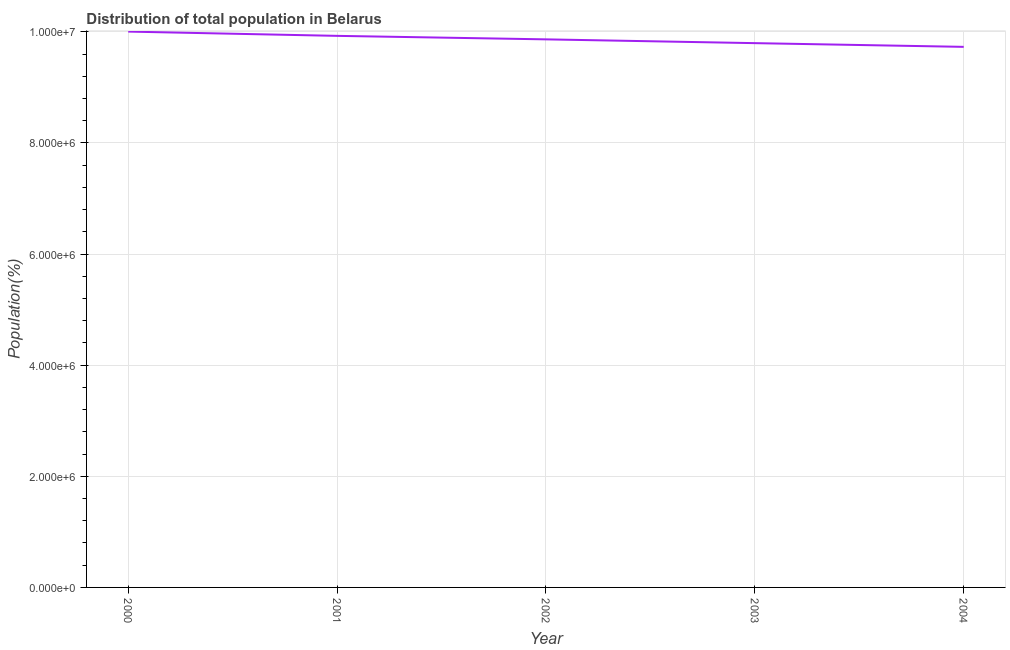What is the population in 2003?
Your answer should be compact. 9.80e+06. Across all years, what is the maximum population?
Provide a short and direct response. 1.00e+07. Across all years, what is the minimum population?
Provide a succinct answer. 9.73e+06. In which year was the population maximum?
Provide a short and direct response. 2000. In which year was the population minimum?
Your answer should be compact. 2004. What is the sum of the population?
Give a very brief answer. 4.93e+07. What is the difference between the population in 2000 and 2002?
Ensure brevity in your answer.  1.40e+05. What is the average population per year?
Your answer should be very brief. 9.86e+06. What is the median population?
Ensure brevity in your answer.  9.86e+06. In how many years, is the population greater than 4800000 %?
Offer a terse response. 5. What is the ratio of the population in 2002 to that in 2003?
Your answer should be compact. 1.01. What is the difference between the highest and the second highest population?
Your response must be concise. 7.70e+04. What is the difference between the highest and the lowest population?
Your answer should be compact. 2.75e+05. How many lines are there?
Offer a very short reply. 1. How many years are there in the graph?
Provide a succinct answer. 5. What is the difference between two consecutive major ticks on the Y-axis?
Ensure brevity in your answer.  2.00e+06. Does the graph contain any zero values?
Offer a terse response. No. What is the title of the graph?
Your response must be concise. Distribution of total population in Belarus . What is the label or title of the Y-axis?
Make the answer very short. Population(%). What is the Population(%) of 2000?
Offer a very short reply. 1.00e+07. What is the Population(%) in 2001?
Offer a terse response. 9.93e+06. What is the Population(%) in 2002?
Provide a succinct answer. 9.86e+06. What is the Population(%) of 2003?
Your answer should be very brief. 9.80e+06. What is the Population(%) of 2004?
Ensure brevity in your answer.  9.73e+06. What is the difference between the Population(%) in 2000 and 2001?
Offer a terse response. 7.70e+04. What is the difference between the Population(%) in 2000 and 2003?
Ensure brevity in your answer.  2.08e+05. What is the difference between the Population(%) in 2000 and 2004?
Your response must be concise. 2.75e+05. What is the difference between the Population(%) in 2001 and 2002?
Ensure brevity in your answer.  6.30e+04. What is the difference between the Population(%) in 2001 and 2003?
Offer a very short reply. 1.31e+05. What is the difference between the Population(%) in 2001 and 2004?
Your response must be concise. 1.98e+05. What is the difference between the Population(%) in 2002 and 2003?
Keep it short and to the point. 6.80e+04. What is the difference between the Population(%) in 2002 and 2004?
Ensure brevity in your answer.  1.35e+05. What is the difference between the Population(%) in 2003 and 2004?
Your answer should be compact. 6.70e+04. What is the ratio of the Population(%) in 2000 to that in 2003?
Offer a very short reply. 1.02. What is the ratio of the Population(%) in 2000 to that in 2004?
Offer a very short reply. 1.03. What is the ratio of the Population(%) in 2001 to that in 2003?
Keep it short and to the point. 1.01. What is the ratio of the Population(%) in 2002 to that in 2003?
Offer a very short reply. 1.01. What is the ratio of the Population(%) in 2002 to that in 2004?
Provide a succinct answer. 1.01. 